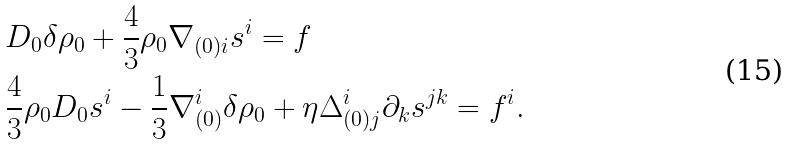<formula> <loc_0><loc_0><loc_500><loc_500>& D _ { 0 } \delta \rho _ { 0 } + \frac { 4 } { 3 } \rho _ { 0 } \nabla _ { ( 0 ) i } s ^ { i } = f \\ & \frac { 4 } { 3 } \rho _ { 0 } D _ { 0 } s ^ { i } - \frac { 1 } { 3 } \nabla _ { ( 0 ) } ^ { i } \delta \rho _ { 0 } + \eta \Delta ^ { i } _ { ( 0 ) j } \partial _ { k } s ^ { j k } = f ^ { i } .</formula> 